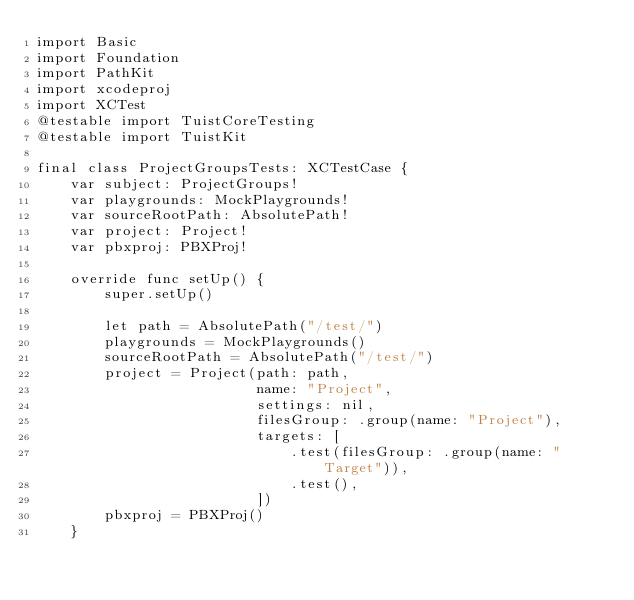Convert code to text. <code><loc_0><loc_0><loc_500><loc_500><_Swift_>import Basic
import Foundation
import PathKit
import xcodeproj
import XCTest
@testable import TuistCoreTesting
@testable import TuistKit

final class ProjectGroupsTests: XCTestCase {
    var subject: ProjectGroups!
    var playgrounds: MockPlaygrounds!
    var sourceRootPath: AbsolutePath!
    var project: Project!
    var pbxproj: PBXProj!

    override func setUp() {
        super.setUp()

        let path = AbsolutePath("/test/")
        playgrounds = MockPlaygrounds()
        sourceRootPath = AbsolutePath("/test/")
        project = Project(path: path,
                          name: "Project",
                          settings: nil,
                          filesGroup: .group(name: "Project"),
                          targets: [
                              .test(filesGroup: .group(name: "Target")),
                              .test(),
                          ])
        pbxproj = PBXProj()
    }
</code> 